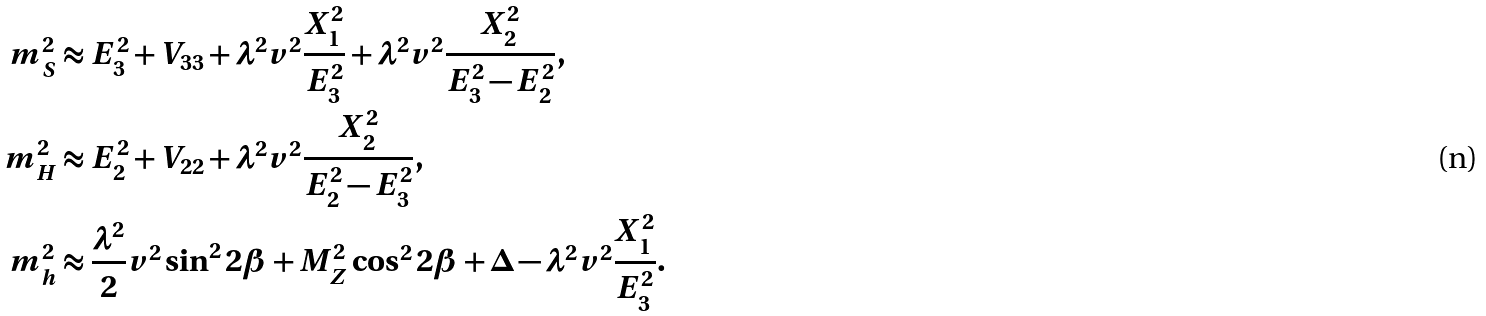<formula> <loc_0><loc_0><loc_500><loc_500>m _ { S } ^ { 2 } & \approx E _ { 3 } ^ { 2 } + V _ { 3 3 } + \lambda ^ { 2 } v ^ { 2 } \frac { X _ { 1 } ^ { 2 } } { E _ { 3 } ^ { 2 } } + \lambda ^ { 2 } v ^ { 2 } \frac { X _ { 2 } ^ { 2 } } { E _ { 3 } ^ { 2 } - E _ { 2 } ^ { 2 } } , \\ m _ { H } ^ { 2 } & \approx E _ { 2 } ^ { 2 } + V _ { 2 2 } + \lambda ^ { 2 } v ^ { 2 } \frac { X _ { 2 } ^ { 2 } } { E _ { 2 } ^ { 2 } - E _ { 3 } ^ { 2 } } , \\ m _ { h } ^ { 2 } & \approx \frac { \lambda ^ { 2 } } { 2 } v ^ { 2 } \sin ^ { 2 } 2 \beta + M _ { Z } ^ { 2 } \cos ^ { 2 } 2 \beta + \Delta - \lambda ^ { 2 } v ^ { 2 } \frac { X _ { 1 } ^ { 2 } } { E _ { 3 } ^ { 2 } } .</formula> 